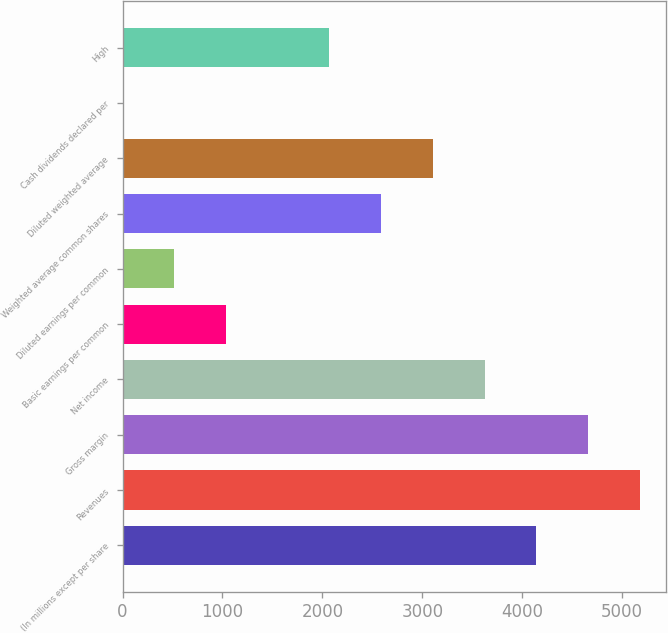Convert chart. <chart><loc_0><loc_0><loc_500><loc_500><bar_chart><fcel>(In millions except per share<fcel>Revenues<fcel>Gross margin<fcel>Net income<fcel>Basic earnings per common<fcel>Diluted earnings per common<fcel>Weighted average common shares<fcel>Diluted weighted average<fcel>Cash dividends declared per<fcel>High<nl><fcel>4140.03<fcel>5175<fcel>4657.5<fcel>3622.56<fcel>1035.21<fcel>517.74<fcel>2587.62<fcel>3105.09<fcel>0.27<fcel>2070.15<nl></chart> 